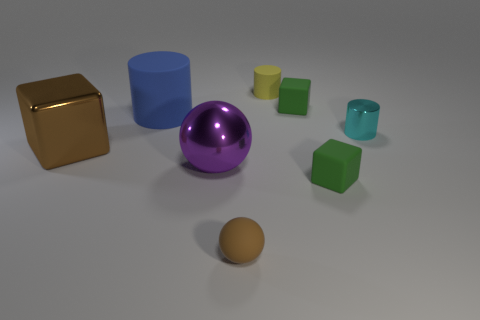Add 1 purple metal cylinders. How many objects exist? 9 Subtract all cubes. How many objects are left? 5 Add 8 small matte spheres. How many small matte spheres exist? 9 Subtract 0 purple cylinders. How many objects are left? 8 Subtract all purple rubber blocks. Subtract all tiny cyan metal things. How many objects are left? 7 Add 4 big balls. How many big balls are left? 5 